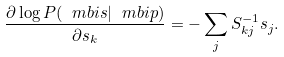<formula> <loc_0><loc_0><loc_500><loc_500>\frac { \partial \log { P } ( { \ m b i s } | \ m b i p ) } { \partial { s } _ { k } } = - \sum _ { j } { S } ^ { - 1 } _ { k j } { s } _ { j } { . }</formula> 